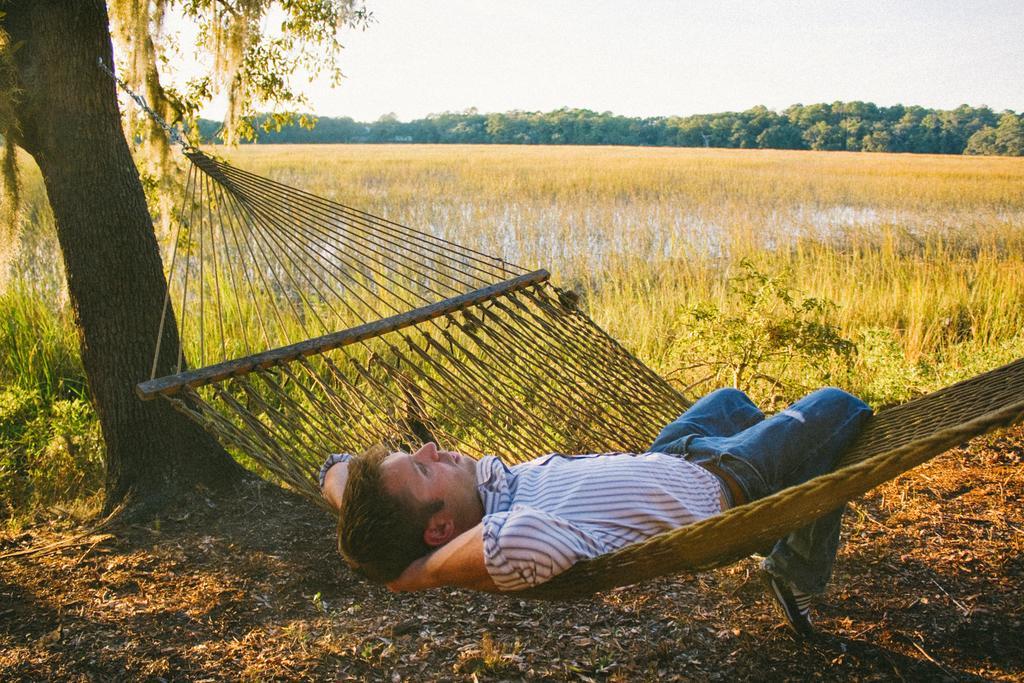How would you summarize this image in a sentence or two? This picture is taken from outside of the city. In this image, in the middle, we can see a man lying in the cradle. In the background, we can see some trees, plants. On the left side, we can also see a wooden trunk, trees. At the top, we can see a sky, at the bottom, we can see grass, water and a land with some stones. 